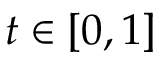<formula> <loc_0><loc_0><loc_500><loc_500>t \in \left [ 0 , 1 \right ]</formula> 